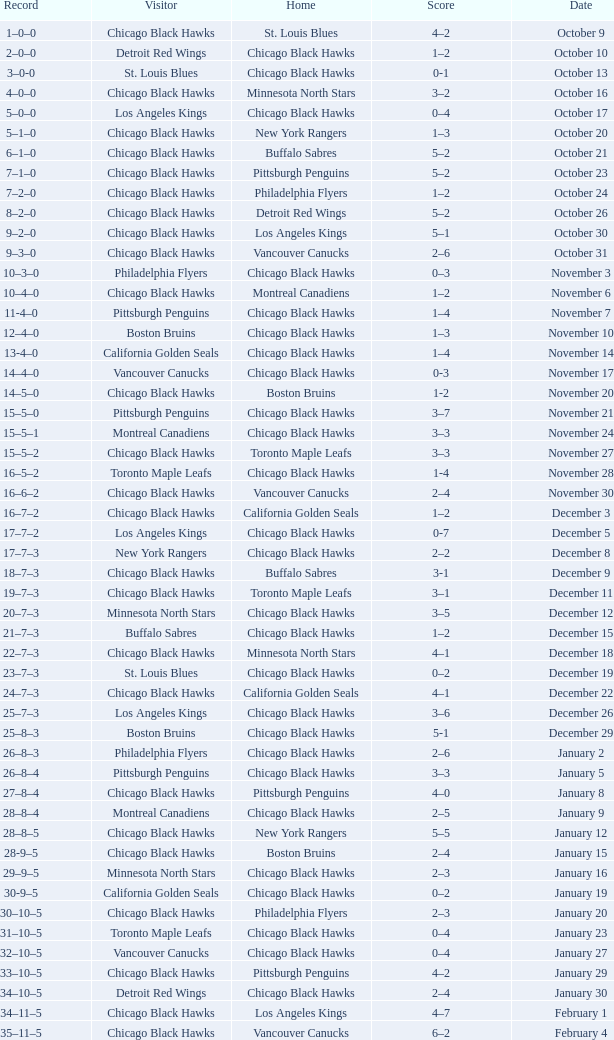What is the Score of the Chicago Black Hawks Home game with the Visiting Vancouver Canucks on November 17? 0-3. 